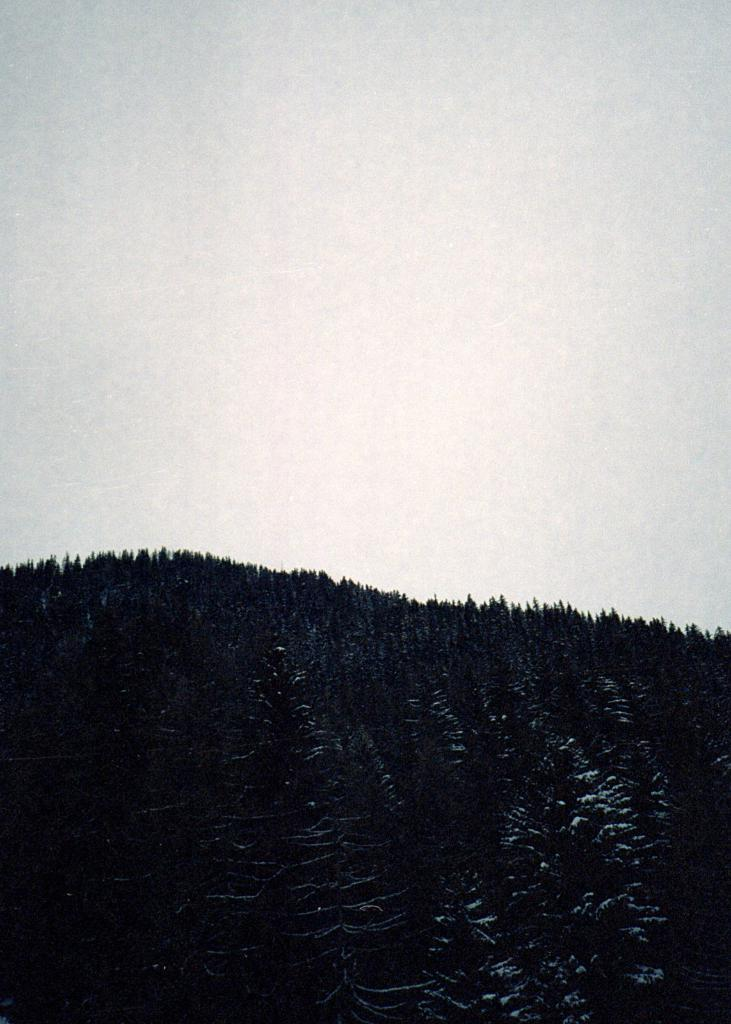What is the main subject of the picture? The main subject of the picture is a mountain. What can be seen on the mountain? There are trees on the mountain. What is the condition of the sky in the picture? The sky is clear in the picture. How many clocks can be seen on the mountain in the image? There are no clocks present in the image; it features a mountain with trees. Can you tell me how the army is helping the people on the mountain in the image? There is no army or people present in the image, only a mountain with trees and a clear sky. 